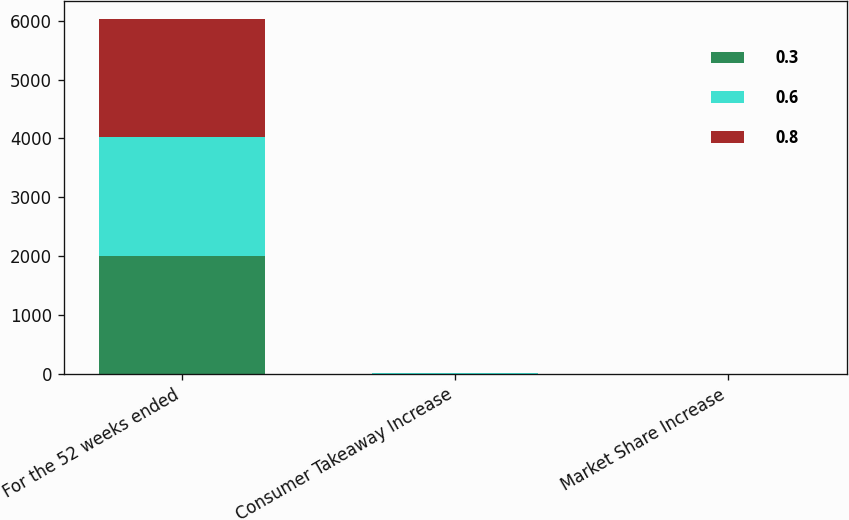Convert chart. <chart><loc_0><loc_0><loc_500><loc_500><stacked_bar_chart><ecel><fcel>For the 52 weeks ended<fcel>Consumer Takeaway Increase<fcel>Market Share Increase<nl><fcel>0.3<fcel>2012<fcel>5.7<fcel>0.6<nl><fcel>0.6<fcel>2011<fcel>7.8<fcel>0.8<nl><fcel>0.8<fcel>2010<fcel>5.3<fcel>0.3<nl></chart> 